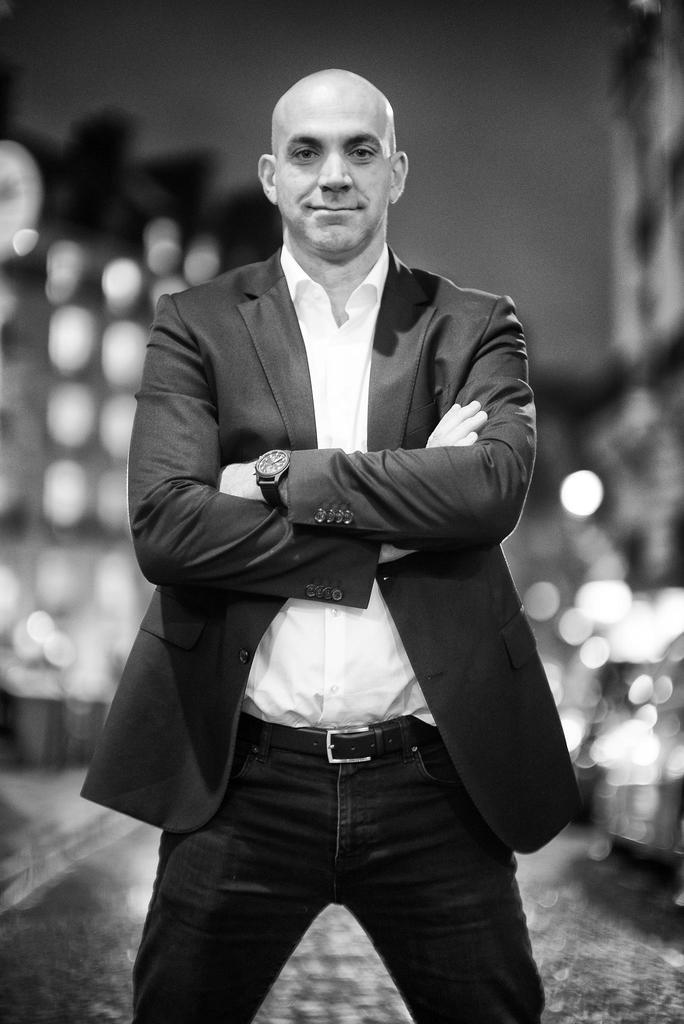What is the color scheme of the image? The image is black and white. Who or what can be seen in the image? There is a man standing in the image. Where is the man standing? The man is standing on a path. Can you describe the background of the image? The background of the image is blurred. How does the cream affect the man's clothing in the image? There is no cream present in the image, so it cannot affect the man's clothing. 